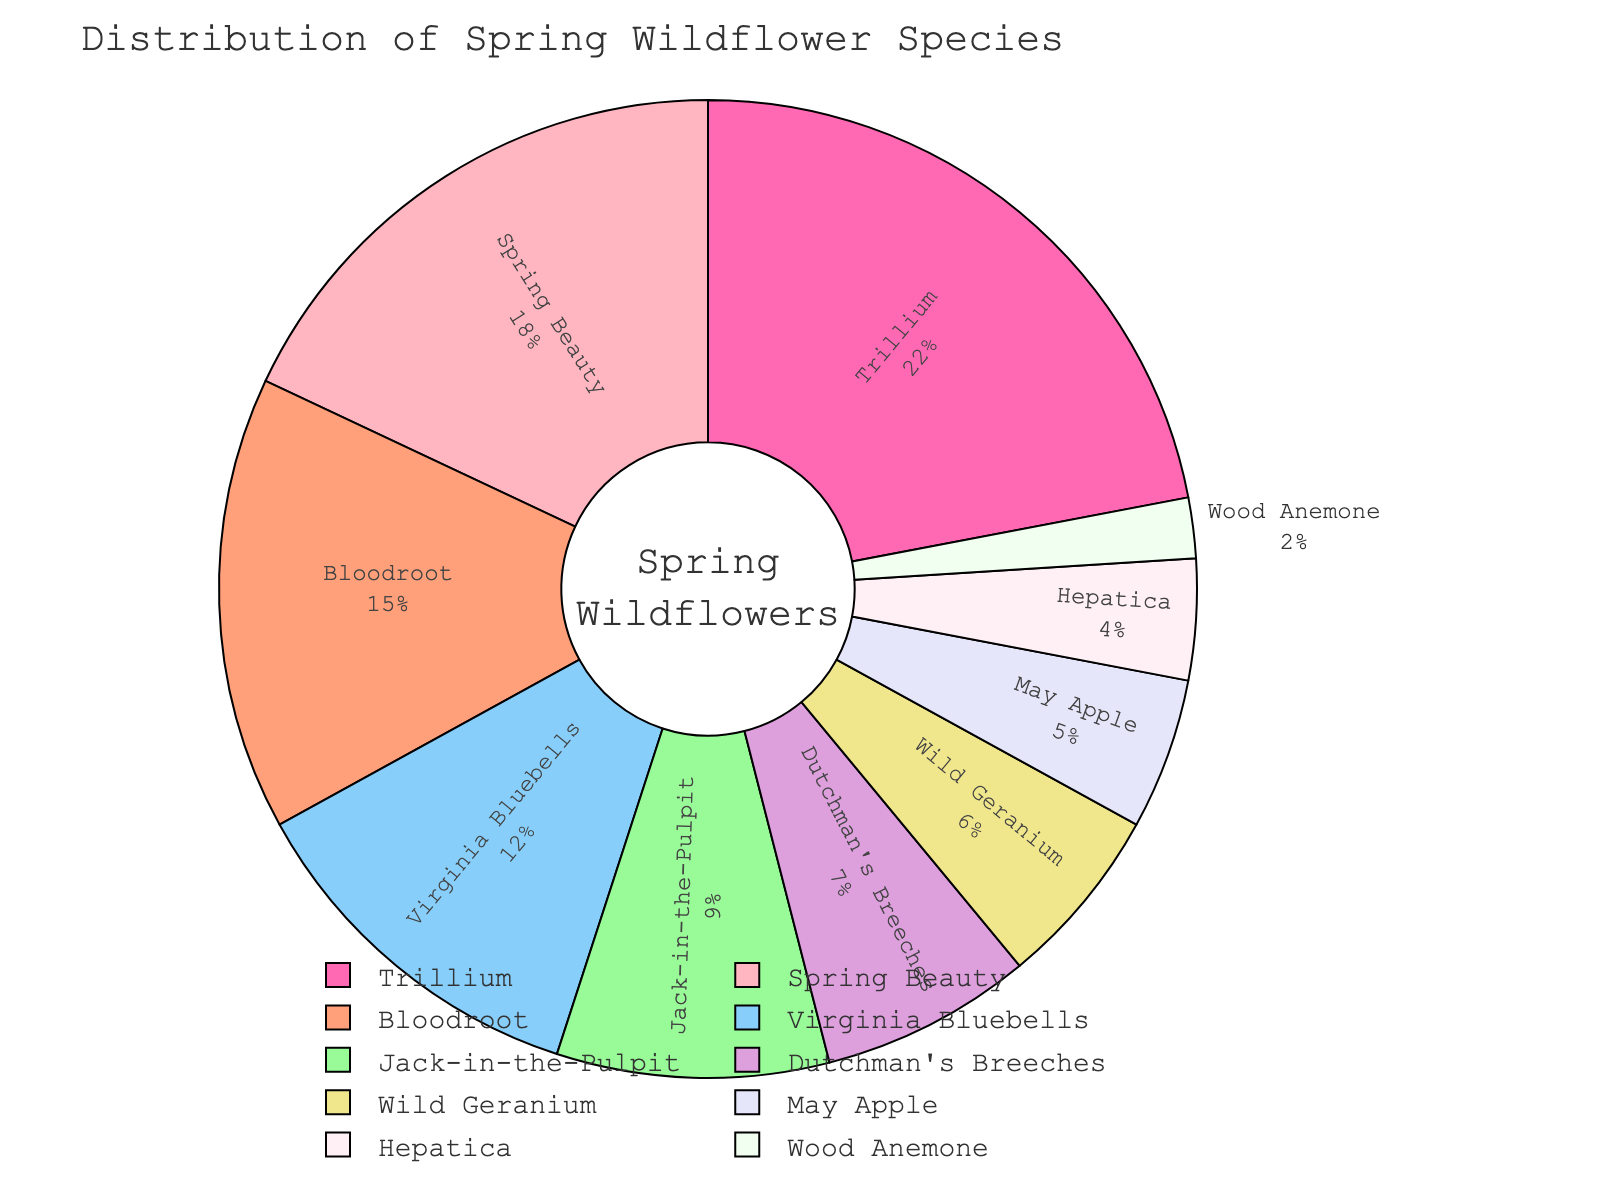What percentage of the total wildflower species is represented by Trillium and Virginia Bluebells combined? Trillium represents 22% and Virginia Bluebells represent 12%. Adding these two percentages gives 22% + 12% = 34%.
Answer: 34% Which species has a smaller share, Jack-in-the-Pulpit or Wild Geranium? Jack-in-the-Pulpit has a 9% share, while Wild Geranium has a 6% share. Comparing these, 9% is greater than 6%, so Wild Geranium has a smaller share.
Answer: Wild Geranium Identify the species represented by the bright pink segment of the pie chart. The bright pink color on the pie chart is linked to Trillium.
Answer: Trillium Which species have a combined share equal to or greater than Spring Beauty? Spring Beauty has an 18% share. Combining May Apple (5%) and Bloodroot (15%) yields 5% + 15% = 20%, which is greater than 18%.
Answer: May Apple and Bloodroot What is the difference between the percentages of Dutchman's Breeches and Hepatica? Dutchman's Breeches has a 7% share, and Hepatica has a 4% share. The difference is 7% - 4% = 3%.
Answer: 3% Which species occupies the smallest section of the pie chart, and what is its percentage? The species with the smallest section is Wood Anemone, which occupies 2% of the pie chart.
Answer: Wood Anemone, 2% Which species has a larger share, Bloodroot or Wild Geranium? Bloodroot has a 15% share, while Wild Geranium has a 6% share. Since 15% is greater than 6%, Bloodroot has a larger share.
Answer: Bloodroot If you combine the shares of Bloodroot and Jack-in-the-Pulpit, will their total be more or less than Trillium's share? Bloodroot has 15% and Jack-in-the-Pulpit has 9%. Their total is 15% + 9% = 24%, which is greater than Trillium's 22%.
Answer: More 